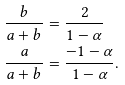Convert formula to latex. <formula><loc_0><loc_0><loc_500><loc_500>\frac { b } { a + b } & = \frac { 2 } { 1 - \alpha } \\ \frac { a } { a + b } & = \frac { - 1 - \alpha } { 1 - \alpha } .</formula> 